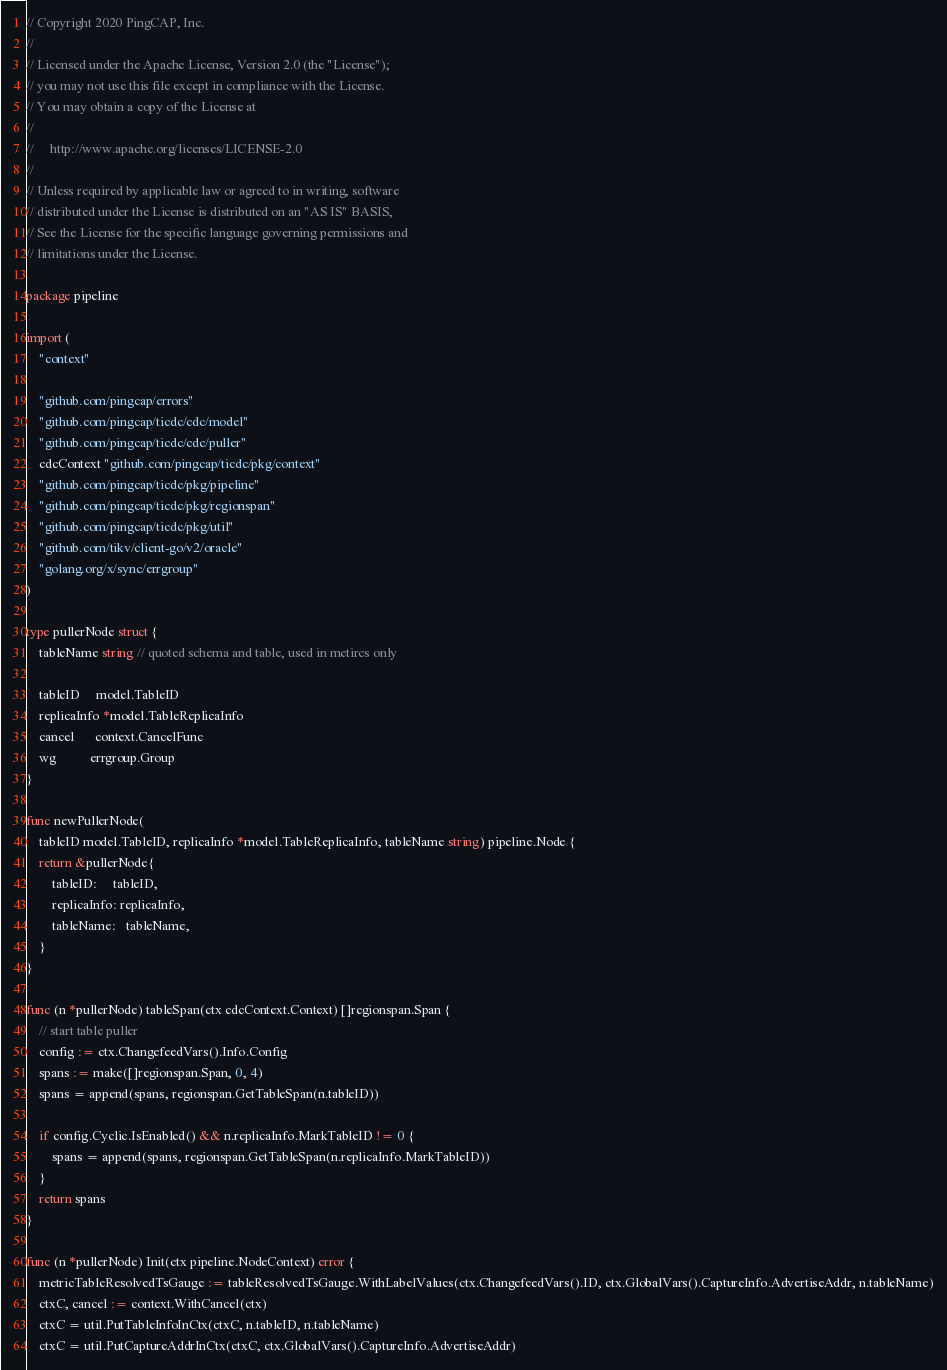<code> <loc_0><loc_0><loc_500><loc_500><_Go_>// Copyright 2020 PingCAP, Inc.
//
// Licensed under the Apache License, Version 2.0 (the "License");
// you may not use this file except in compliance with the License.
// You may obtain a copy of the License at
//
//     http://www.apache.org/licenses/LICENSE-2.0
//
// Unless required by applicable law or agreed to in writing, software
// distributed under the License is distributed on an "AS IS" BASIS,
// See the License for the specific language governing permissions and
// limitations under the License.

package pipeline

import (
	"context"

	"github.com/pingcap/errors"
	"github.com/pingcap/ticdc/cdc/model"
	"github.com/pingcap/ticdc/cdc/puller"
	cdcContext "github.com/pingcap/ticdc/pkg/context"
	"github.com/pingcap/ticdc/pkg/pipeline"
	"github.com/pingcap/ticdc/pkg/regionspan"
	"github.com/pingcap/ticdc/pkg/util"
	"github.com/tikv/client-go/v2/oracle"
	"golang.org/x/sync/errgroup"
)

type pullerNode struct {
	tableName string // quoted schema and table, used in metircs only

	tableID     model.TableID
	replicaInfo *model.TableReplicaInfo
	cancel      context.CancelFunc
	wg          errgroup.Group
}

func newPullerNode(
	tableID model.TableID, replicaInfo *model.TableReplicaInfo, tableName string) pipeline.Node {
	return &pullerNode{
		tableID:     tableID,
		replicaInfo: replicaInfo,
		tableName:   tableName,
	}
}

func (n *pullerNode) tableSpan(ctx cdcContext.Context) []regionspan.Span {
	// start table puller
	config := ctx.ChangefeedVars().Info.Config
	spans := make([]regionspan.Span, 0, 4)
	spans = append(spans, regionspan.GetTableSpan(n.tableID))

	if config.Cyclic.IsEnabled() && n.replicaInfo.MarkTableID != 0 {
		spans = append(spans, regionspan.GetTableSpan(n.replicaInfo.MarkTableID))
	}
	return spans
}

func (n *pullerNode) Init(ctx pipeline.NodeContext) error {
	metricTableResolvedTsGauge := tableResolvedTsGauge.WithLabelValues(ctx.ChangefeedVars().ID, ctx.GlobalVars().CaptureInfo.AdvertiseAddr, n.tableName)
	ctxC, cancel := context.WithCancel(ctx)
	ctxC = util.PutTableInfoInCtx(ctxC, n.tableID, n.tableName)
	ctxC = util.PutCaptureAddrInCtx(ctxC, ctx.GlobalVars().CaptureInfo.AdvertiseAddr)</code> 